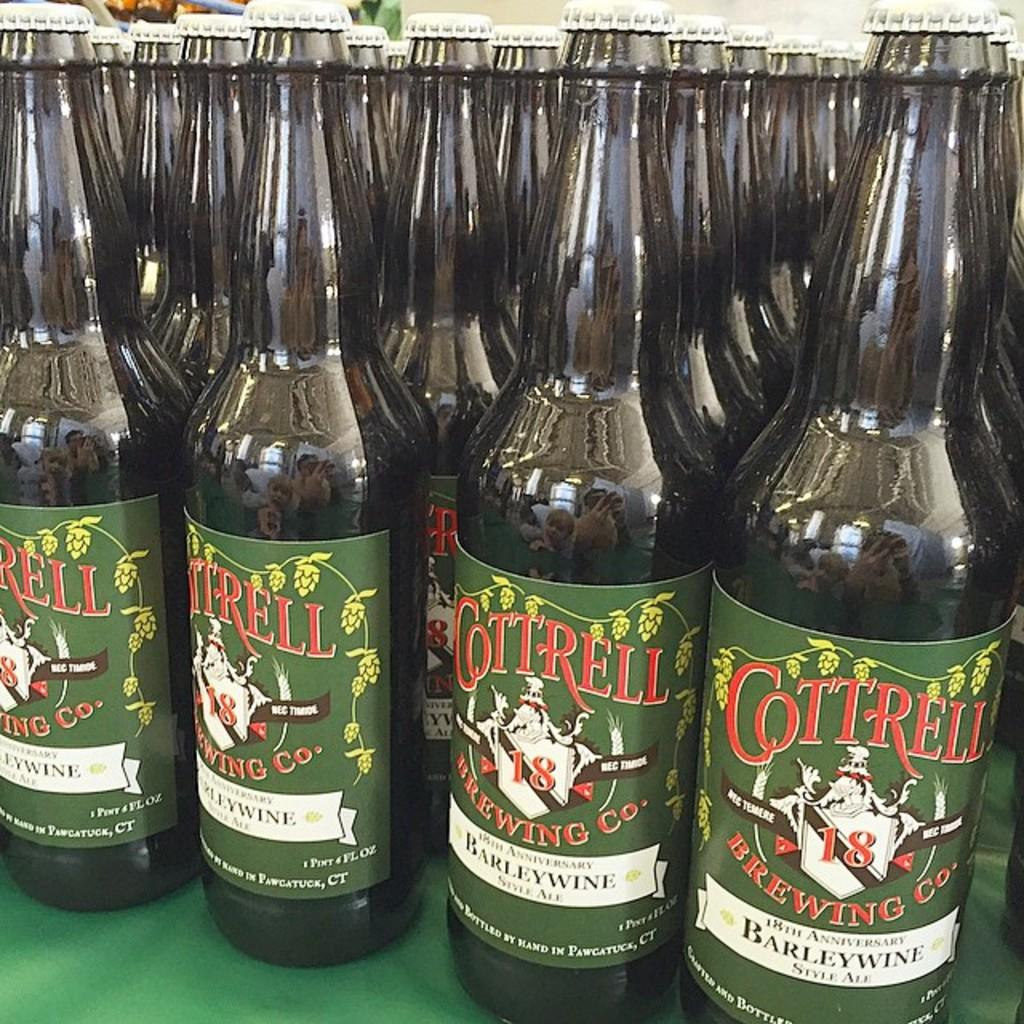What objects are present in the image? There are bottles in the image. What can be seen on the bottles? The bottles have stickers on them. What is the color of the floor in the image? The bottles are placed on a green floor. How are the bottles arranged in the image? The bottles are arranged in a line. What effect do the giants have on the bottles in the image? There are no giants present in the image, so there is no effect on the bottles from giants. Can you tell me how many basketballs are visible in the image? There are no basketballs present in the image. 